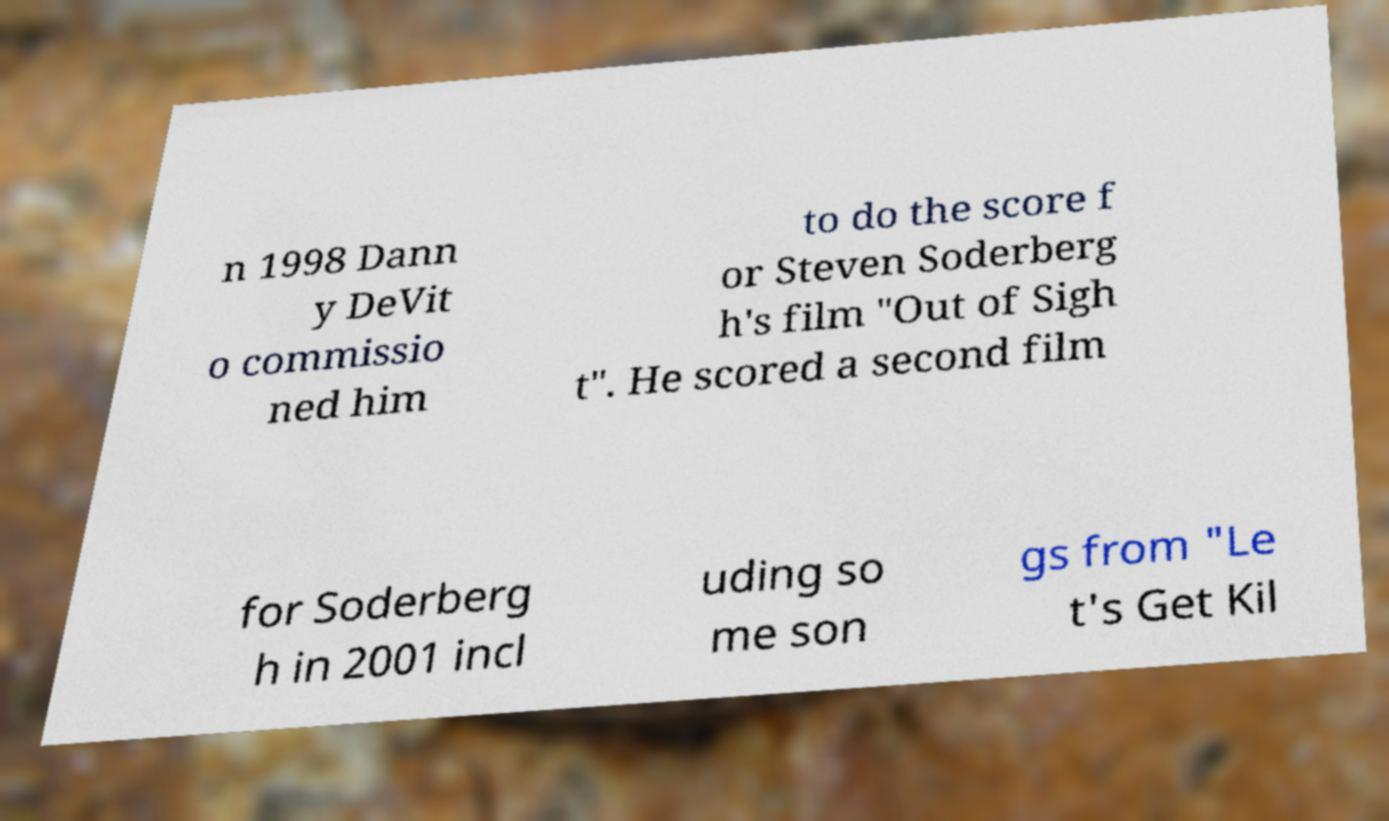Please identify and transcribe the text found in this image. n 1998 Dann y DeVit o commissio ned him to do the score f or Steven Soderberg h's film "Out of Sigh t". He scored a second film for Soderberg h in 2001 incl uding so me son gs from "Le t's Get Kil 